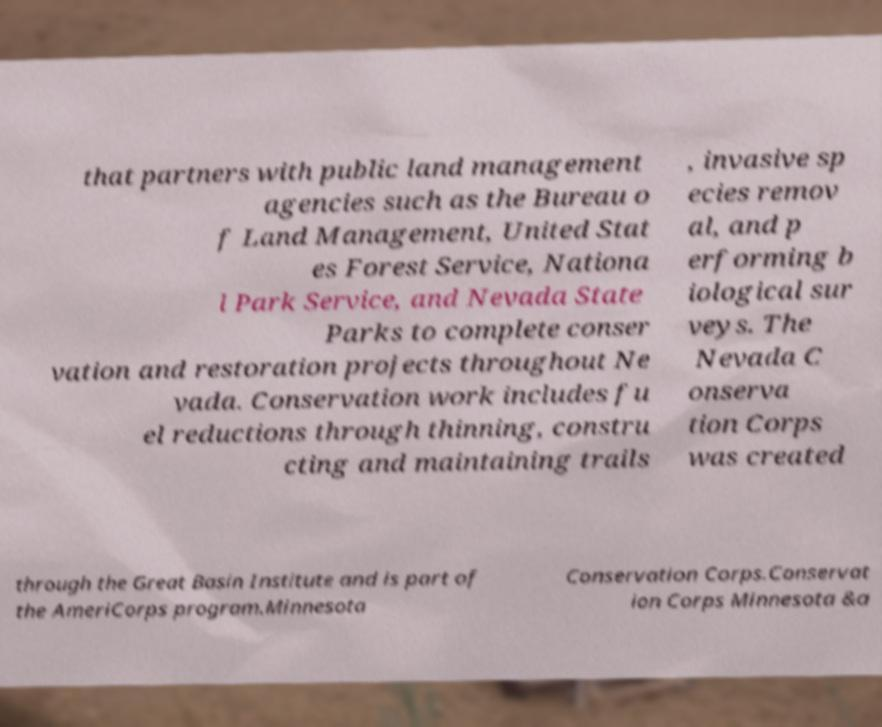Could you extract and type out the text from this image? that partners with public land management agencies such as the Bureau o f Land Management, United Stat es Forest Service, Nationa l Park Service, and Nevada State Parks to complete conser vation and restoration projects throughout Ne vada. Conservation work includes fu el reductions through thinning, constru cting and maintaining trails , invasive sp ecies remov al, and p erforming b iological sur veys. The Nevada C onserva tion Corps was created through the Great Basin Institute and is part of the AmeriCorps program.Minnesota Conservation Corps.Conservat ion Corps Minnesota &a 